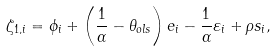<formula> <loc_0><loc_0><loc_500><loc_500>\zeta _ { 1 , i } = \phi _ { i } + \left ( \frac { 1 } { \alpha } - \theta _ { o l s } \right ) e _ { i } - \frac { 1 } { \alpha } \varepsilon _ { i } + \rho s _ { i } ,</formula> 